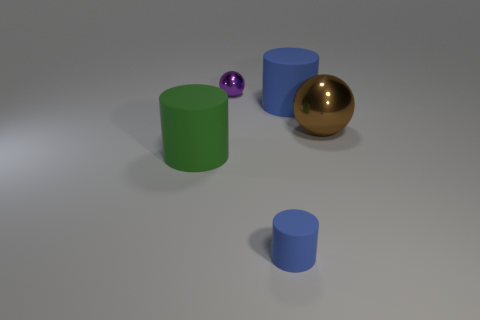Add 1 tiny gray metal balls. How many objects exist? 6 Subtract all spheres. How many objects are left? 3 Subtract 2 balls. How many balls are left? 0 Subtract all brown balls. Subtract all green cylinders. How many balls are left? 1 Subtract all yellow cubes. How many purple balls are left? 1 Subtract all large gray shiny balls. Subtract all tiny blue rubber cylinders. How many objects are left? 4 Add 4 big spheres. How many big spheres are left? 5 Add 1 big blue cylinders. How many big blue cylinders exist? 2 Subtract all blue cylinders. How many cylinders are left? 1 Subtract all large green matte cylinders. How many cylinders are left? 2 